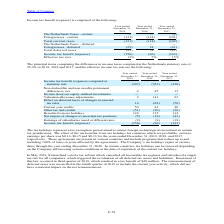According to Stmicroelectronics's financial document, What is tax holidays? The tax holidays represent a tax exemption period aimed to attract foreign technological investment in certain tax jurisdictions.. The document states: "The tax holidays represent a tax exemption period aimed to attract foreign technological investment in certain tax jurisdictions. The effect of the ta..." Also, What was the effect of tax holidays on the basic earnings per share in 2019? According to the financial document, $0.14. The relevant text states: "ch are profitable, on basic earnings per share was $0.14, $0.15 and $0.13 for the years ended December 31, 2019, 2018, and 2017, respectively. These agreeme..." Also, What was the tax benefit of the enactment of the tax reform introduced by Switzerland in third quarter 2019? According to the financial document, $20 million. The relevant text states: "uarter of 2019, which resulted in a tax benefit of $20 million. The remeasurement of deferred taxes was reconciled in the fourth quarter of 2019 to include the cu..." Also, can you calculate: What is the increase/ (decrease) in Income tax benefit (expense) computed at statutory rate from December 31, 2018 to 2019? Based on the calculation: 297-353, the result is -56 (in millions). This is based on the information: "nefit (expense) computed at statutory rate (297) (353) (238) tax benefit (expense) computed at statutory rate (297) (353) (238)..." The key data points involved are: 297, 353. Also, can you calculate: What is the increase/ (decrease) in Benefits from tax holidays from December 31, 2018 to 2019? Based on the calculation: 129-135, the result is -6 (in millions). This is based on the information: "Benefits from tax holidays 129 135 114 Benefits from tax holidays 129 135 114..." The key data points involved are: 129, 135. Also, can you calculate: What is the increase/ (decrease) in Income tax benefit (expense) from December 31, 2018 to 2019? Based on the calculation: 156-96, the result is 60 (in millions). This is based on the information: "Income tax benefit (expense) (156) (96) (143) Income tax benefit (expense) (156) (96) (143)..." The key data points involved are: 156, 96. 